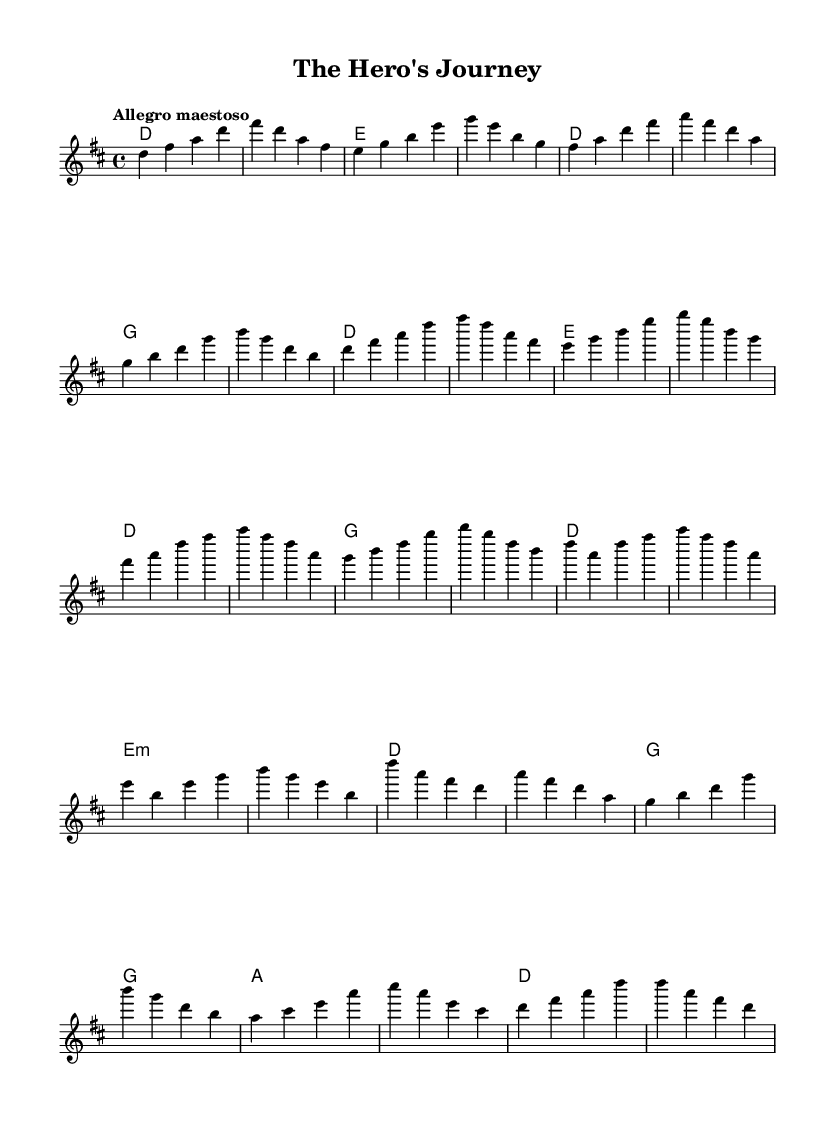What is the key signature of this music? The key signature is indicated by the number of sharps or flats at the beginning of the staff. In this case, the music is in D major, which has two sharps (F# and C#).
Answer: D major What is the time signature of this music? The time signature appears at the beginning of the staff and indicates the beats per measure. Here, the time signature is 4/4, meaning there are four beats in each measure.
Answer: 4/4 What is the tempo marking of this piece? The tempo is provided in the score, indicating how fast the piece should be played. In this case, the marking is "Allegro maestoso," which suggests a fast and majestic tempo.
Answer: Allegro maestoso How many measures are in the main theme section? To determine the number of measures, count the measures explicitly written in the main theme section from the score. The main theme consists of eight measures in total.
Answer: 8 What chord does the introduction start with? The harmonies for the introduction section appear at the beginning of the chord section. The first chord listed here is D major.
Answer: D Which section features the "Battle Section"? The score is divided into different thematic sections, and the "Battle Section" is labeled explicitly in the melody part. This section includes the first four measures after the main theme.
Answer: Battle Section What is the final chord of the piece? The final chord can be identified by looking at the last harmony in the score. The last chord is D major, which concludes the composition.
Answer: D 